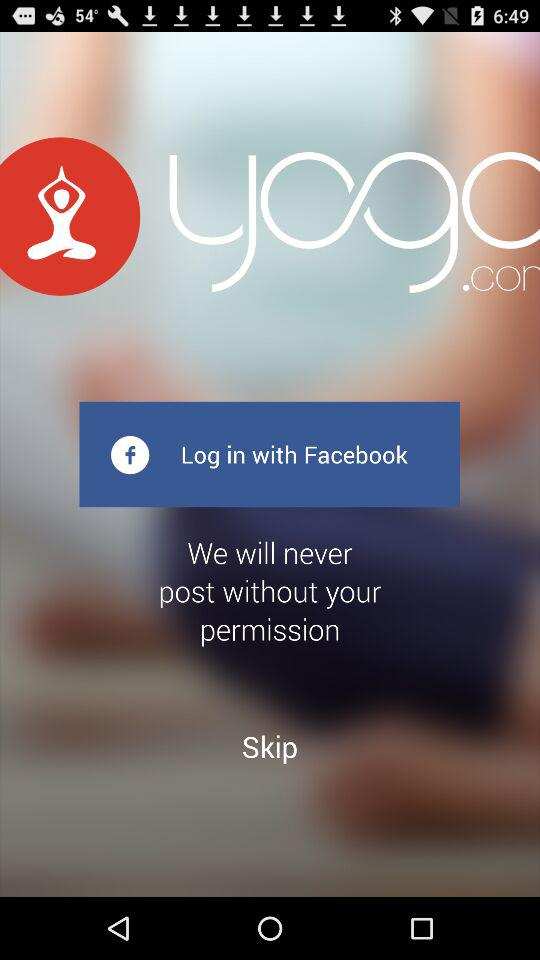What is the name of the application? The name of the application is "Yoga.com". 